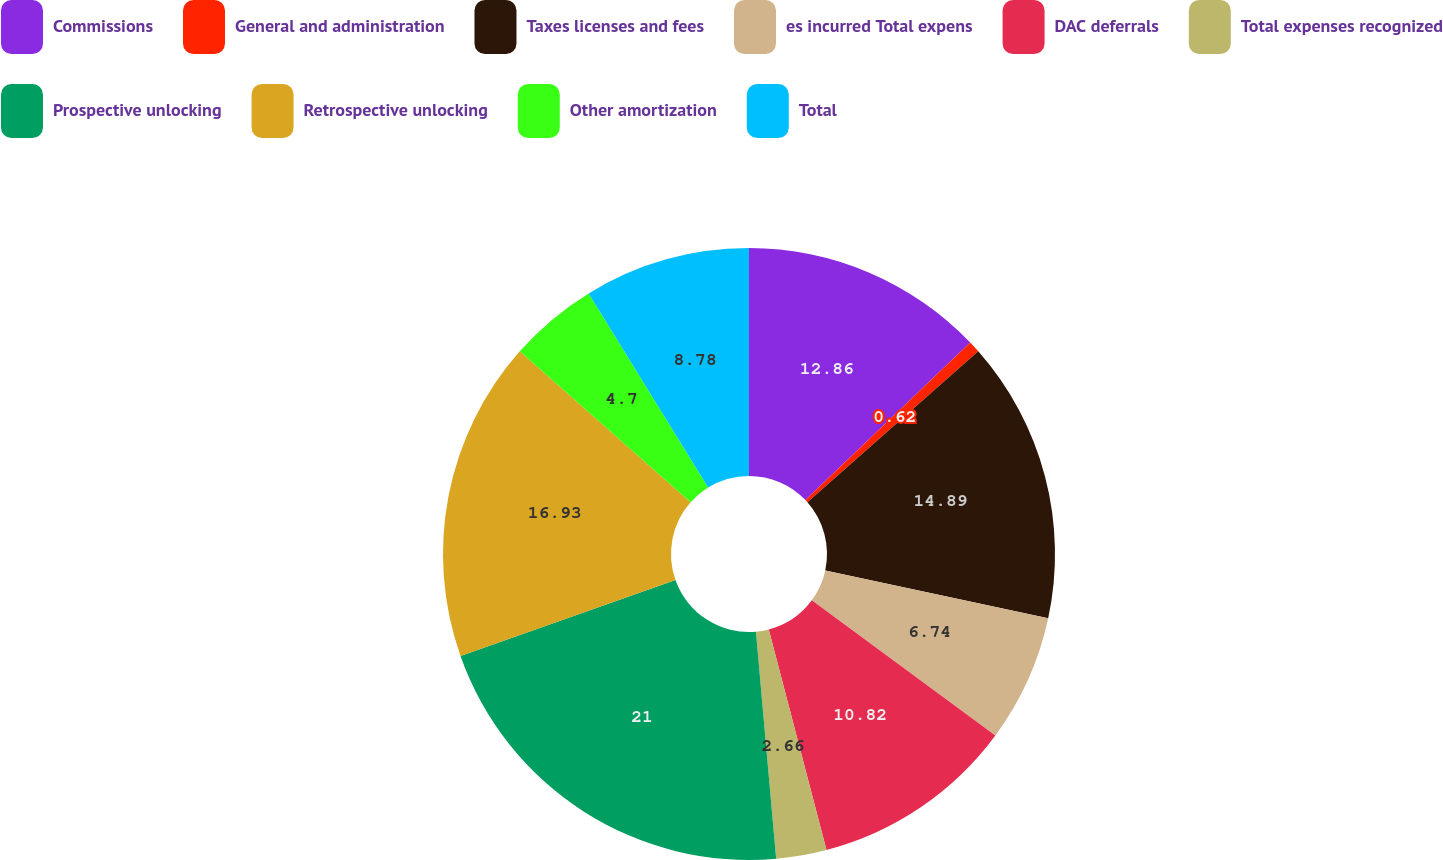Convert chart to OTSL. <chart><loc_0><loc_0><loc_500><loc_500><pie_chart><fcel>Commissions<fcel>General and administration<fcel>Taxes licenses and fees<fcel>es incurred Total expens<fcel>DAC deferrals<fcel>Total expenses recognized<fcel>Prospective unlocking<fcel>Retrospective unlocking<fcel>Other amortization<fcel>Total<nl><fcel>12.86%<fcel>0.62%<fcel>14.89%<fcel>6.74%<fcel>10.82%<fcel>2.66%<fcel>21.01%<fcel>16.93%<fcel>4.7%<fcel>8.78%<nl></chart> 